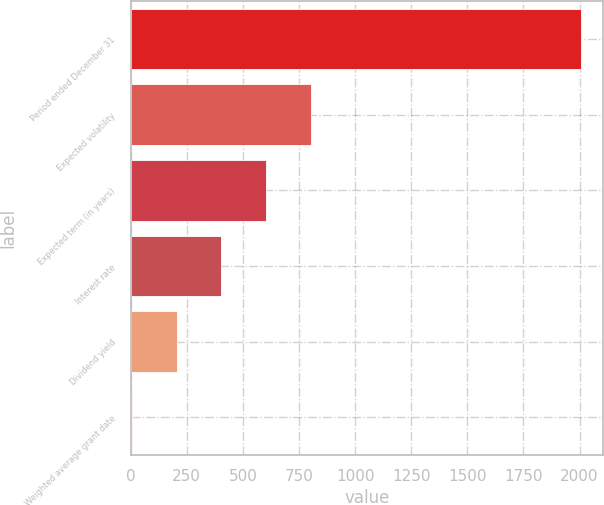<chart> <loc_0><loc_0><loc_500><loc_500><bar_chart><fcel>Period ended December 31<fcel>Expected volatility<fcel>Expected term (in years)<fcel>Interest rate<fcel>Dividend yield<fcel>Weighted average grant date<nl><fcel>2006<fcel>804.88<fcel>604.7<fcel>404.52<fcel>204.34<fcel>4.15<nl></chart> 